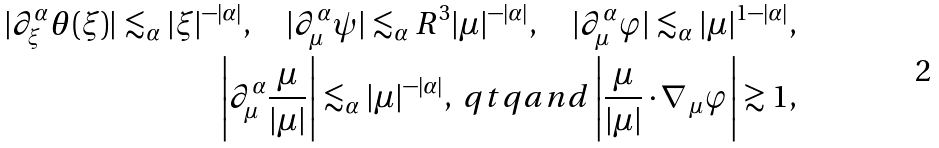<formula> <loc_0><loc_0><loc_500><loc_500>| \partial _ { \xi } ^ { \alpha } \theta ( \xi ) | \lesssim _ { \alpha } | \xi | ^ { - | \alpha | } , \quad | \partial _ { \mu } ^ { \alpha } \psi | \lesssim _ { \alpha } R ^ { 3 } | \mu | ^ { - | \alpha | } , \quad | \partial _ { \mu } ^ { \alpha } \varphi | \lesssim _ { \alpha } | \mu | ^ { 1 - | \alpha | } , \\ \left | \partial _ { \mu } ^ { \alpha } \frac { \mu } { | \mu | } \right | \lesssim _ { \alpha } | \mu | ^ { - | \alpha | } , \ q t q { a n d } \left | \frac { \mu } { | \mu | } \cdot \nabla _ { \, \mu } \varphi \right | \gtrsim 1 ,</formula> 